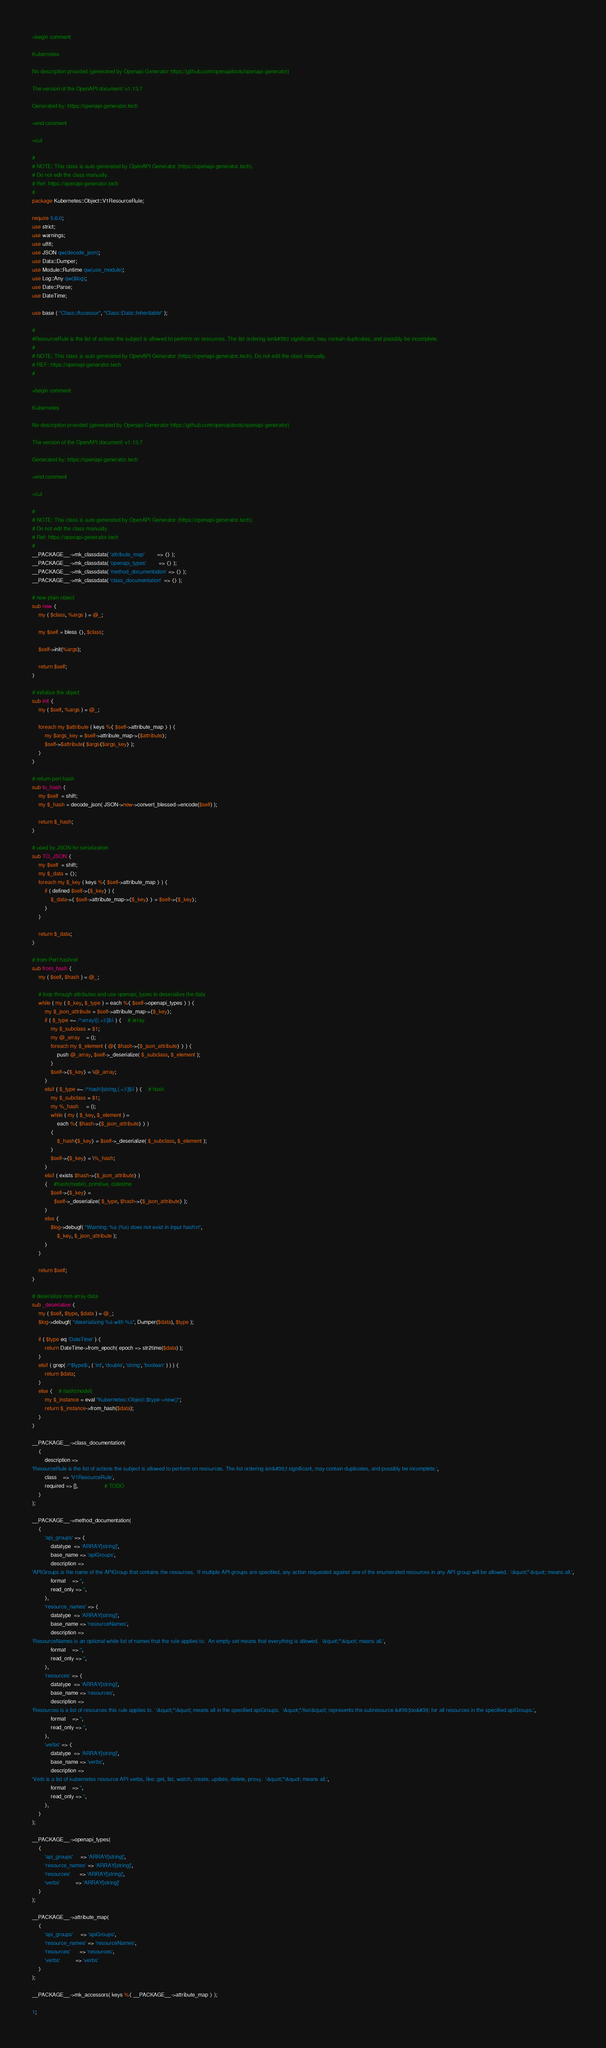<code> <loc_0><loc_0><loc_500><loc_500><_Perl_>
=begin comment

Kubernetes

No description provided (generated by Openapi Generator https://github.com/openapitools/openapi-generator)

The version of the OpenAPI document: v1.13.7

Generated by: https://openapi-generator.tech

=end comment

=cut

#
# NOTE: This class is auto generated by OpenAPI Generator (https://openapi-generator.tech).
# Do not edit the class manually.
# Ref: https://openapi-generator.tech
#
package Kubernetes::Object::V1ResourceRule;

require 5.6.0;
use strict;
use warnings;
use utf8;
use JSON qw(decode_json);
use Data::Dumper;
use Module::Runtime qw(use_module);
use Log::Any qw($log);
use Date::Parse;
use DateTime;

use base ( "Class::Accessor", "Class::Data::Inheritable" );

#
#ResourceRule is the list of actions the subject is allowed to perform on resources. The list ordering isn&#39;t significant, may contain duplicates, and possibly be incomplete.
#
# NOTE: This class is auto generated by OpenAPI Generator (https://openapi-generator.tech). Do not edit the class manually.
# REF: https://openapi-generator.tech
#

=begin comment

Kubernetes

No description provided (generated by Openapi Generator https://github.com/openapitools/openapi-generator)

The version of the OpenAPI document: v1.13.7

Generated by: https://openapi-generator.tech

=end comment

=cut

#
# NOTE: This class is auto generated by OpenAPI Generator (https://openapi-generator.tech).
# Do not edit the class manually.
# Ref: https://openapi-generator.tech
#
__PACKAGE__->mk_classdata( 'attribute_map'        => {} );
__PACKAGE__->mk_classdata( 'openapi_types'        => {} );
__PACKAGE__->mk_classdata( 'method_documentation' => {} );
__PACKAGE__->mk_classdata( 'class_documentation'  => {} );

# new plain object
sub new {
    my ( $class, %args ) = @_;

    my $self = bless {}, $class;

    $self->init(%args);

    return $self;
}

# initialize the object
sub init {
    my ( $self, %args ) = @_;

    foreach my $attribute ( keys %{ $self->attribute_map } ) {
        my $args_key = $self->attribute_map->{$attribute};
        $self->$attribute( $args{$args_key} );
    }
}

# return perl hash
sub to_hash {
    my $self  = shift;
    my $_hash = decode_json( JSON->new->convert_blessed->encode($self) );

    return $_hash;
}

# used by JSON for serialization
sub TO_JSON {
    my $self  = shift;
    my $_data = {};
    foreach my $_key ( keys %{ $self->attribute_map } ) {
        if ( defined $self->{$_key} ) {
            $_data->{ $self->attribute_map->{$_key} } = $self->{$_key};
        }
    }

    return $_data;
}

# from Perl hashref
sub from_hash {
    my ( $self, $hash ) = @_;

    # loop through attributes and use openapi_types to deserialize the data
    while ( my ( $_key, $_type ) = each %{ $self->openapi_types } ) {
        my $_json_attribute = $self->attribute_map->{$_key};
        if ( $_type =~ /^array\[(.+)\]$/i ) {    # array
            my $_subclass = $1;
            my @_array    = ();
            foreach my $_element ( @{ $hash->{$_json_attribute} } ) {
                push @_array, $self->_deserialize( $_subclass, $_element );
            }
            $self->{$_key} = \@_array;
        }
        elsif ( $_type =~ /^hash\[string,(.+)\]$/i ) {    # hash
            my $_subclass = $1;
            my %_hash     = ();
            while ( my ( $_key, $_element ) =
                each %{ $hash->{$_json_attribute} } )
            {
                $_hash{$_key} = $self->_deserialize( $_subclass, $_element );
            }
            $self->{$_key} = \%_hash;
        }
        elsif ( exists $hash->{$_json_attribute} )
        {    #hash(model), primitive, datetime
            $self->{$_key} =
              $self->_deserialize( $_type, $hash->{$_json_attribute} );
        }
        else {
            $log->debugf( "Warning: %s (%s) does not exist in input hash\n",
                $_key, $_json_attribute );
        }
    }

    return $self;
}

# deserialize non-array data
sub _deserialize {
    my ( $self, $type, $data ) = @_;
    $log->debugf( "deserializing %s with %s", Dumper($data), $type );

    if ( $type eq 'DateTime' ) {
        return DateTime->from_epoch( epoch => str2time($data) );
    }
    elsif ( grep( /^$type$/, ( 'int', 'double', 'string', 'boolean' ) ) ) {
        return $data;
    }
    else {    # hash(model)
        my $_instance = eval "Kubernetes::Object::$type->new()";
        return $_instance->from_hash($data);
    }
}

__PACKAGE__->class_documentation(
    {
        description =>
'ResourceRule is the list of actions the subject is allowed to perform on resources. The list ordering isn&#39;t significant, may contain duplicates, and possibly be incomplete.',
        class    => 'V1ResourceRule',
        required => [],                 # TODO
    }
);

__PACKAGE__->method_documentation(
    {
        'api_groups' => {
            datatype  => 'ARRAY[string]',
            base_name => 'apiGroups',
            description =>
'APIGroups is the name of the APIGroup that contains the resources.  If multiple API groups are specified, any action requested against one of the enumerated resources in any API group will be allowed.  \&quot;*\&quot; means all.',
            format    => '',
            read_only => '',
        },
        'resource_names' => {
            datatype  => 'ARRAY[string]',
            base_name => 'resourceNames',
            description =>
'ResourceNames is an optional white list of names that the rule applies to.  An empty set means that everything is allowed.  \&quot;*\&quot; means all.',
            format    => '',
            read_only => '',
        },
        'resources' => {
            datatype  => 'ARRAY[string]',
            base_name => 'resources',
            description =>
'Resources is a list of resources this rule applies to.  \&quot;*\&quot; means all in the specified apiGroups.  \&quot;*/foo\&quot; represents the subresource &#39;foo&#39; for all resources in the specified apiGroups.',
            format    => '',
            read_only => '',
        },
        'verbs' => {
            datatype  => 'ARRAY[string]',
            base_name => 'verbs',
            description =>
'Verb is a list of kubernetes resource API verbs, like: get, list, watch, create, update, delete, proxy.  \&quot;*\&quot; means all.',
            format    => '',
            read_only => '',
        },
    }
);

__PACKAGE__->openapi_types(
    {
        'api_groups'     => 'ARRAY[string]',
        'resource_names' => 'ARRAY[string]',
        'resources'      => 'ARRAY[string]',
        'verbs'          => 'ARRAY[string]'
    }
);

__PACKAGE__->attribute_map(
    {
        'api_groups'     => 'apiGroups',
        'resource_names' => 'resourceNames',
        'resources'      => 'resources',
        'verbs'          => 'verbs'
    }
);

__PACKAGE__->mk_accessors( keys %{ __PACKAGE__->attribute_map } );

1;
</code> 